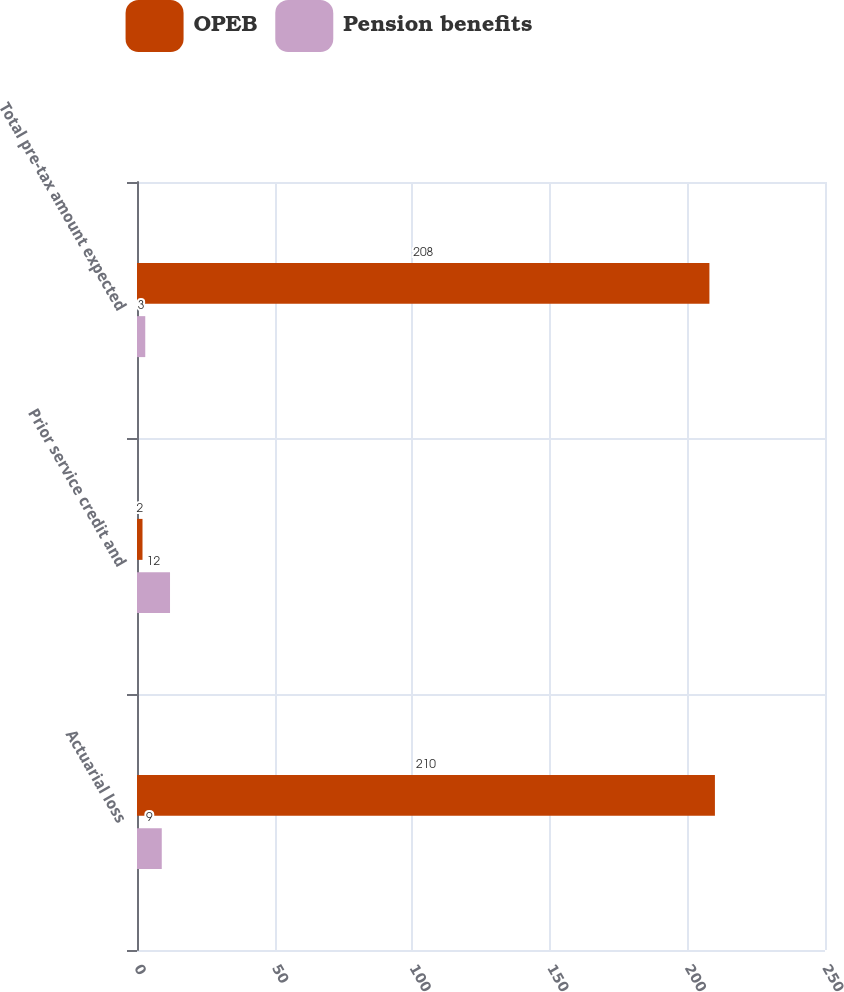Convert chart. <chart><loc_0><loc_0><loc_500><loc_500><stacked_bar_chart><ecel><fcel>Actuarial loss<fcel>Prior service credit and<fcel>Total pre-tax amount expected<nl><fcel>OPEB<fcel>210<fcel>2<fcel>208<nl><fcel>Pension benefits<fcel>9<fcel>12<fcel>3<nl></chart> 